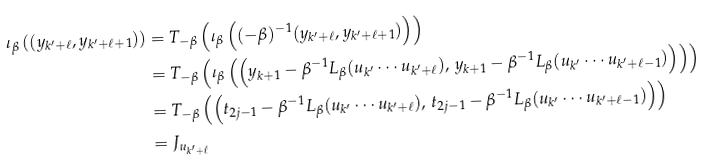Convert formula to latex. <formula><loc_0><loc_0><loc_500><loc_500>\iota _ { \beta } \left ( ( y _ { k ^ { \prime } + \ell } , y _ { k ^ { \prime } + \ell + 1 } ) \right ) & = T _ { - \beta } \left ( \iota _ { \beta } \left ( ( - \beta ) ^ { - 1 } ( y _ { k ^ { \prime } + \ell } , y _ { k ^ { \prime } + \ell + 1 } ) \right ) \right ) \\ & = T _ { - \beta } \left ( \iota _ { \beta } \left ( \left ( y _ { k + 1 } - \beta ^ { - 1 } L _ { \beta } ( u _ { k ^ { \prime } } \cdots u _ { k ^ { \prime } + \ell } ) , \, y _ { k + 1 } - \beta ^ { - 1 } L _ { \beta } ( u _ { k ^ { \prime } } \cdots u _ { k ^ { \prime } + \ell - 1 } ) \right ) \right ) \right ) \\ & = T _ { - \beta } \left ( \left ( t _ { 2 j - 1 } - \beta ^ { - 1 } L _ { \beta } ( u _ { k ^ { \prime } } \cdots u _ { k ^ { \prime } + \ell } ) , \, t _ { 2 j - 1 } - \beta ^ { - 1 } L _ { \beta } ( u _ { k ^ { \prime } } \cdots u _ { k ^ { \prime } + \ell - 1 } ) \right ) \right ) \\ & = J _ { u _ { k ^ { \prime } + \ell } }</formula> 